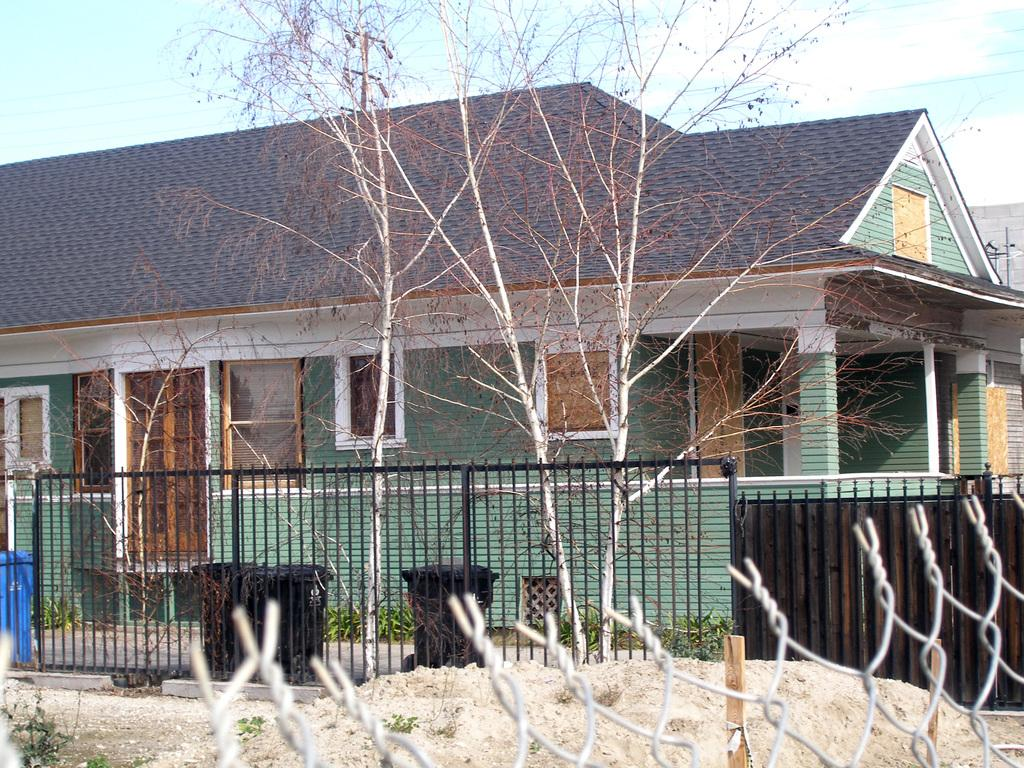What type of barrier can be seen in the image? There is a fence in the image. What type of terrain is visible in the image? There is sand and land visible in the image. What is located behind the fence? A dustbin, trees, and buildings are located behind the fence. What is visible at the top of the image? The sky is visible at the top of the image. What can be seen in the sky? There are clouds in the sky. What else is present in the image? Wires are present in the image. What type of fruit is the father holding in the image? There is no father or fruit present in the image. What type of educational institution can be seen in the image? There is no school present in the image. 